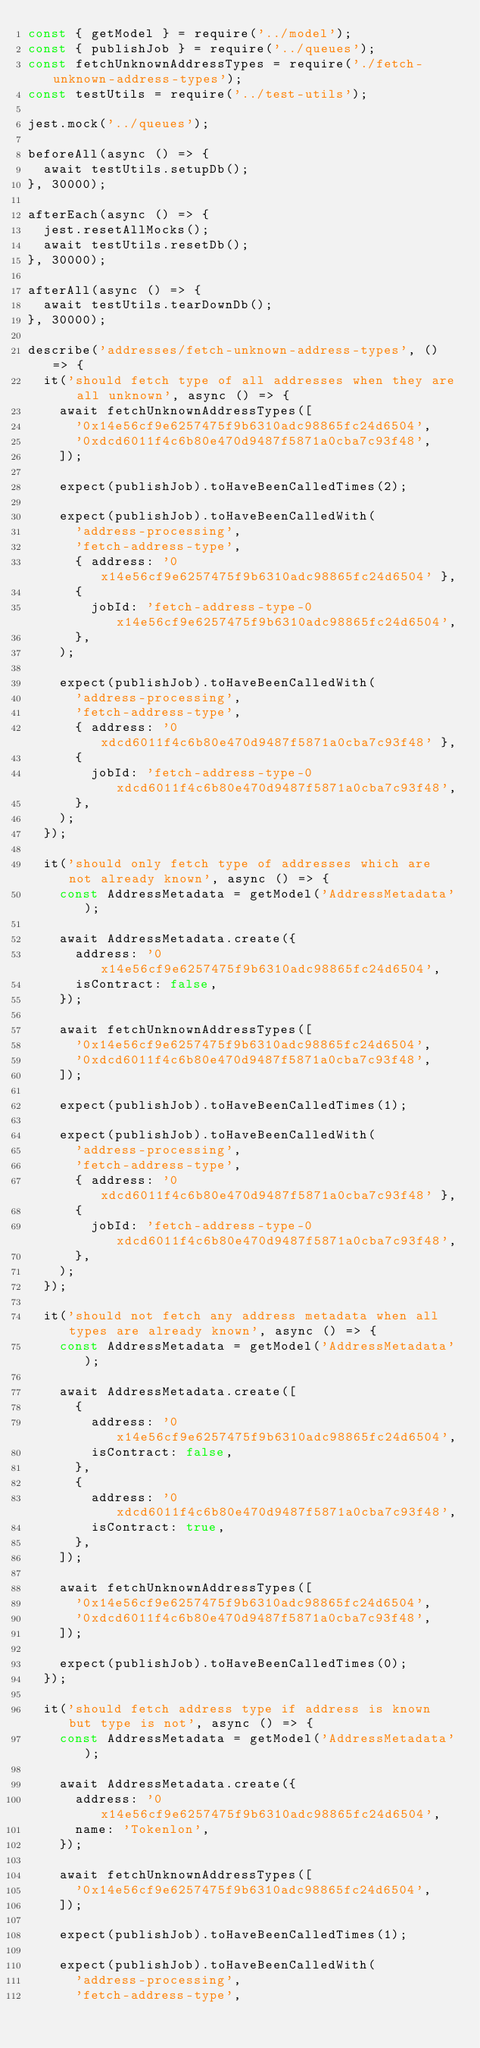Convert code to text. <code><loc_0><loc_0><loc_500><loc_500><_JavaScript_>const { getModel } = require('../model');
const { publishJob } = require('../queues');
const fetchUnknownAddressTypes = require('./fetch-unknown-address-types');
const testUtils = require('../test-utils');

jest.mock('../queues');

beforeAll(async () => {
  await testUtils.setupDb();
}, 30000);

afterEach(async () => {
  jest.resetAllMocks();
  await testUtils.resetDb();
}, 30000);

afterAll(async () => {
  await testUtils.tearDownDb();
}, 30000);

describe('addresses/fetch-unknown-address-types', () => {
  it('should fetch type of all addresses when they are all unknown', async () => {
    await fetchUnknownAddressTypes([
      '0x14e56cf9e6257475f9b6310adc98865fc24d6504',
      '0xdcd6011f4c6b80e470d9487f5871a0cba7c93f48',
    ]);

    expect(publishJob).toHaveBeenCalledTimes(2);

    expect(publishJob).toHaveBeenCalledWith(
      'address-processing',
      'fetch-address-type',
      { address: '0x14e56cf9e6257475f9b6310adc98865fc24d6504' },
      {
        jobId: 'fetch-address-type-0x14e56cf9e6257475f9b6310adc98865fc24d6504',
      },
    );

    expect(publishJob).toHaveBeenCalledWith(
      'address-processing',
      'fetch-address-type',
      { address: '0xdcd6011f4c6b80e470d9487f5871a0cba7c93f48' },
      {
        jobId: 'fetch-address-type-0xdcd6011f4c6b80e470d9487f5871a0cba7c93f48',
      },
    );
  });

  it('should only fetch type of addresses which are not already known', async () => {
    const AddressMetadata = getModel('AddressMetadata');

    await AddressMetadata.create({
      address: '0x14e56cf9e6257475f9b6310adc98865fc24d6504',
      isContract: false,
    });

    await fetchUnknownAddressTypes([
      '0x14e56cf9e6257475f9b6310adc98865fc24d6504',
      '0xdcd6011f4c6b80e470d9487f5871a0cba7c93f48',
    ]);

    expect(publishJob).toHaveBeenCalledTimes(1);

    expect(publishJob).toHaveBeenCalledWith(
      'address-processing',
      'fetch-address-type',
      { address: '0xdcd6011f4c6b80e470d9487f5871a0cba7c93f48' },
      {
        jobId: 'fetch-address-type-0xdcd6011f4c6b80e470d9487f5871a0cba7c93f48',
      },
    );
  });

  it('should not fetch any address metadata when all types are already known', async () => {
    const AddressMetadata = getModel('AddressMetadata');

    await AddressMetadata.create([
      {
        address: '0x14e56cf9e6257475f9b6310adc98865fc24d6504',
        isContract: false,
      },
      {
        address: '0xdcd6011f4c6b80e470d9487f5871a0cba7c93f48',
        isContract: true,
      },
    ]);

    await fetchUnknownAddressTypes([
      '0x14e56cf9e6257475f9b6310adc98865fc24d6504',
      '0xdcd6011f4c6b80e470d9487f5871a0cba7c93f48',
    ]);

    expect(publishJob).toHaveBeenCalledTimes(0);
  });

  it('should fetch address type if address is known but type is not', async () => {
    const AddressMetadata = getModel('AddressMetadata');

    await AddressMetadata.create({
      address: '0x14e56cf9e6257475f9b6310adc98865fc24d6504',
      name: 'Tokenlon',
    });

    await fetchUnknownAddressTypes([
      '0x14e56cf9e6257475f9b6310adc98865fc24d6504',
    ]);

    expect(publishJob).toHaveBeenCalledTimes(1);

    expect(publishJob).toHaveBeenCalledWith(
      'address-processing',
      'fetch-address-type',</code> 